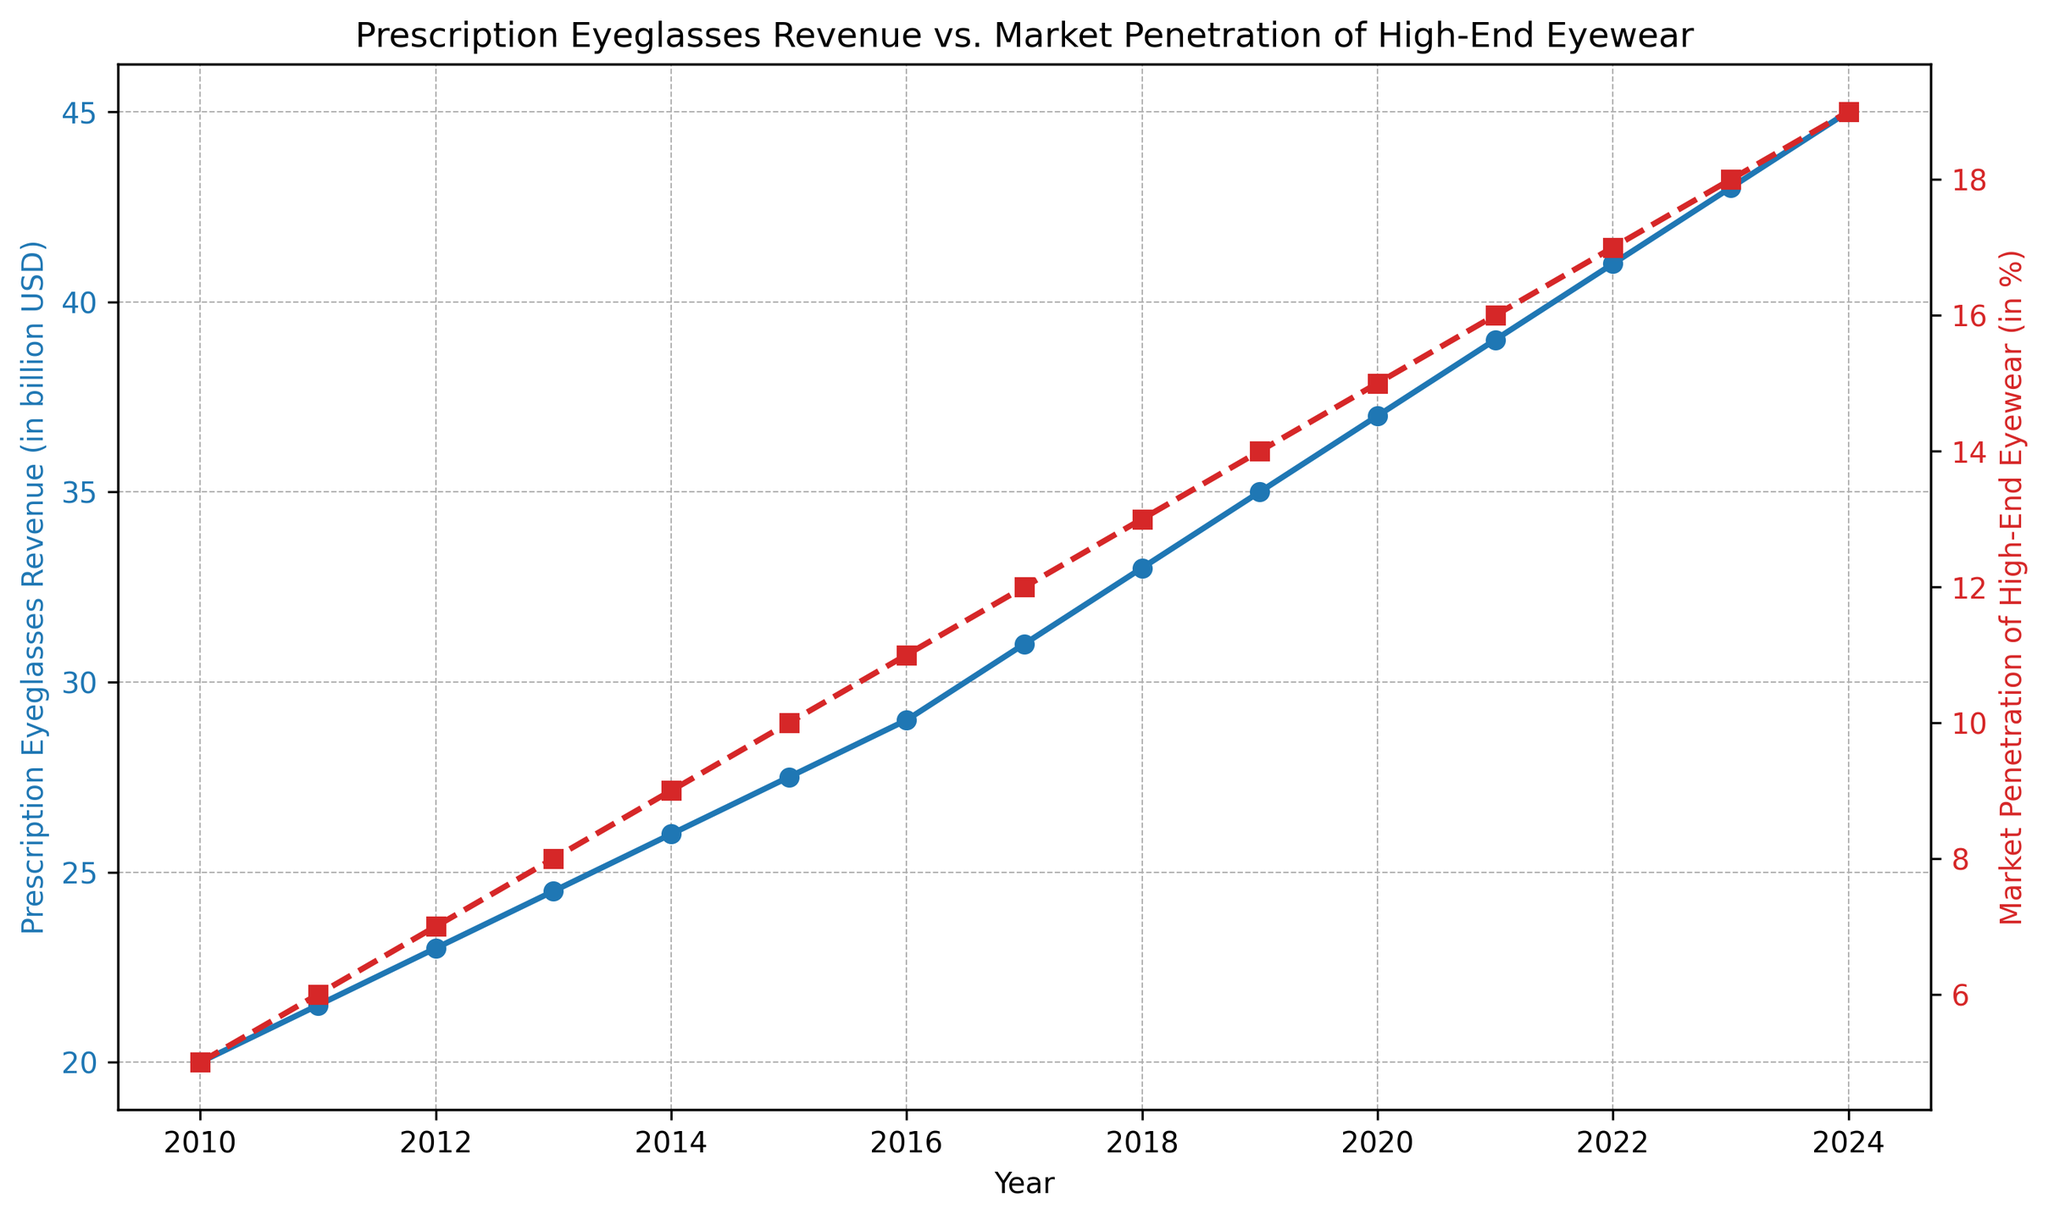What is the overall trend of Prescription Eyeglasses Revenue from 2010 to 2024? To identify the trend, observe the blue line representing the revenue over the years. It continuously ascends from 2010 to 2024, indicating a rising trend in revenue.
Answer: Rising trend How does the Market Penetration of High-End Eyewear change from 2010 to 2024? To identify this change, look at the red line representing market penetration over the years. It rises steadily from 5% in 2010 to 19% in 2024, showing an increasing trend.
Answer: Increasing trend In which year(s) do Prescription Eyeglasses Revenue and Market Penetration of High-End Eyewear intersect or align similarly in terms of their upward trends? Examine both lines and identify the year(s) where they show similar rates of increase. Both lines show a continuous upward trend without any intersection, indicating they are aligned similarly in their trend behavior throughout the period.
Answer: 2010 to 2024 What is the percentage increase in Prescription Eyeglasses Revenue from 2010 to 2020? Calculate the percentage increase using the formula: [(37 - 20) / 20] * 100. This gives a percentage increase of 85%.
Answer: 85% How many years did it take for the Market Penetration of High-End Eyewear to rise from 5% to 15%? Identify the years corresponding to 5% (2010) and 15% (2020). The number of years taken for this rise is 2020 - 2010 = 10 years.
Answer: 10 years Which year marks the highest Market Penetration of High-End Eyewear in the dataset? Look at the red line and find the peak value, which is 19% in the year 2024.
Answer: 2024 What is the overall difference in Prescription Eyeglasses Revenue between 2015 and 2023? Calculate the difference by subtracting the 2015 value (27.5 billion USD) from the 2023 value (43 billion USD), which gives a difference of 15.5 billion USD.
Answer: 15.5 billion USD What is the average annual growth rate of Prescription Eyeglasses Revenue from 2010 to 2024? First, find the total increase in revenue (45 - 20 = 25 billion USD). Then, divide this increase by the number of years (2024 - 2010 = 14 years). Finally, find the average growth rate per year: 25 / 14 ≈ 1.79 billion USD per year.
Answer: 1.79 billion USD per year Compare the Market Penetration of High-End Eyewear between 2012 and 2017. Which year had higher penetration? Refer to the red line values: 2012 had 7% penetration, whereas 2017 had 12%. Therefore, 2017 had a higher penetration.
Answer: 2017 What visual characteristics distinguish the trends for Prescription Eyeglasses Revenue and Market Penetration of High-End Eyewear on the plot? The revenue trend is shown using a blue line with circular markers, which is solid. The market penetration trend is shown with a red line and square markers, which is dashed.
Answer: Blue, solid, circular vs. Red, dashed, square 